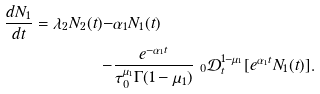Convert formula to latex. <formula><loc_0><loc_0><loc_500><loc_500>\frac { d N _ { 1 } } { d t } = \lambda _ { 2 } N _ { 2 } ( t ) - & \alpha _ { 1 } N _ { 1 } ( t ) \\ - & \frac { e ^ { - \alpha _ { 1 } t } } { \tau _ { 0 } ^ { \mu _ { 1 } } \Gamma ( 1 - \mu _ { 1 } ) } \ _ { 0 } \mathcal { D } _ { t } ^ { 1 - \mu _ { 1 } } [ e ^ { \alpha _ { 1 } t } N _ { 1 } ( t ) ] .</formula> 